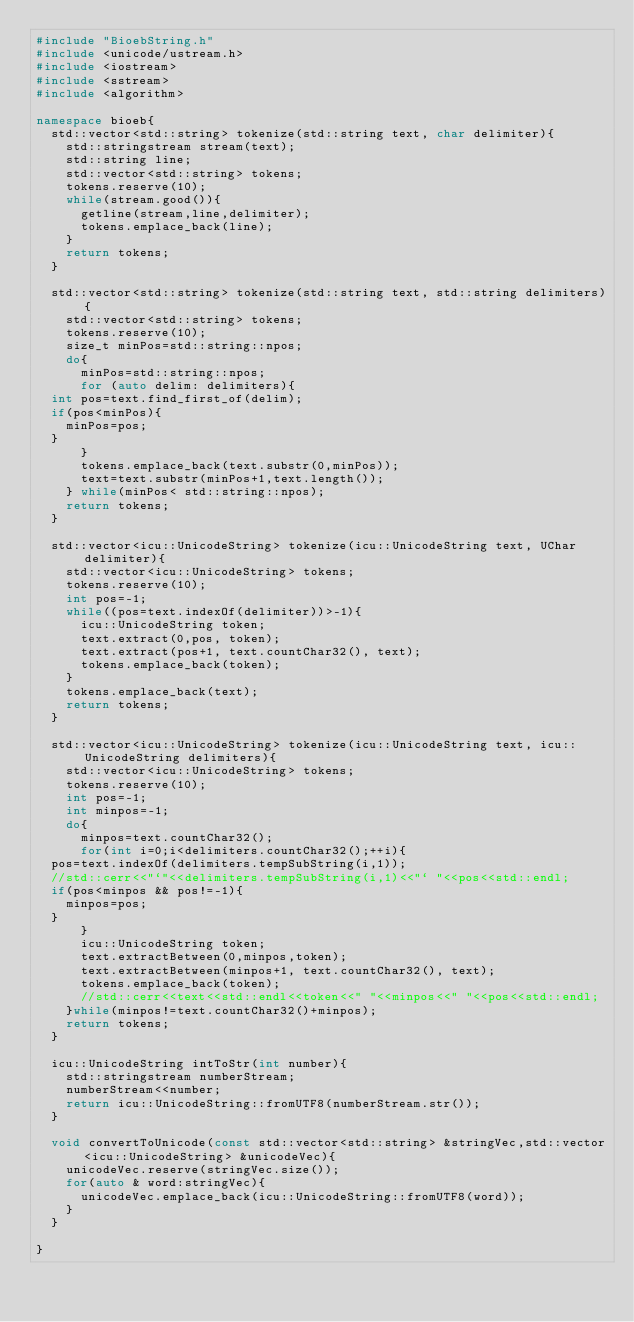Convert code to text. <code><loc_0><loc_0><loc_500><loc_500><_C++_>#include "BioebString.h"
#include <unicode/ustream.h>
#include <iostream>
#include <sstream>
#include <algorithm>

namespace bioeb{
  std::vector<std::string> tokenize(std::string text, char delimiter){
    std::stringstream stream(text);
    std::string line;
    std::vector<std::string> tokens;
    tokens.reserve(10);
    while(stream.good()){
      getline(stream,line,delimiter);
      tokens.emplace_back(line);
    }
    return tokens;
  }

  std::vector<std::string> tokenize(std::string text, std::string delimiters){
    std::vector<std::string> tokens;
    tokens.reserve(10);
    size_t minPos=std::string::npos;
    do{
      minPos=std::string::npos;
      for (auto delim: delimiters){
	int pos=text.find_first_of(delim);
	if(pos<minPos){
	  minPos=pos;
	}
      }
      tokens.emplace_back(text.substr(0,minPos));
      text=text.substr(minPos+1,text.length());
    } while(minPos< std::string::npos);
    return tokens;
  }

  std::vector<icu::UnicodeString> tokenize(icu::UnicodeString text, UChar delimiter){
    std::vector<icu::UnicodeString> tokens;
    tokens.reserve(10);
    int pos=-1;
    while((pos=text.indexOf(delimiter))>-1){
      icu::UnicodeString token;
      text.extract(0,pos, token);
      text.extract(pos+1, text.countChar32(), text);
      tokens.emplace_back(token);
    }
    tokens.emplace_back(text);
    return tokens;
  }

  std::vector<icu::UnicodeString> tokenize(icu::UnicodeString text, icu::UnicodeString delimiters){
    std::vector<icu::UnicodeString> tokens;
    tokens.reserve(10);
    int pos=-1;
    int minpos=-1;
    do{
      minpos=text.countChar32();
      for(int i=0;i<delimiters.countChar32();++i){
	pos=text.indexOf(delimiters.tempSubString(i,1));
	//std::cerr<<"`"<<delimiters.tempSubString(i,1)<<"` "<<pos<<std::endl;
	if(pos<minpos && pos!=-1){
	  minpos=pos;
	}
      }
      icu::UnicodeString token;
      text.extractBetween(0,minpos,token);
      text.extractBetween(minpos+1, text.countChar32(), text);
      tokens.emplace_back(token);
      //std::cerr<<text<<std::endl<<token<<" "<<minpos<<" "<<pos<<std::endl;
    }while(minpos!=text.countChar32()+minpos);
    return tokens;
  }

  icu::UnicodeString intToStr(int number){
    std::stringstream numberStream;
    numberStream<<number;
    return icu::UnicodeString::fromUTF8(numberStream.str());
  }

  void convertToUnicode(const std::vector<std::string> &stringVec,std::vector<icu::UnicodeString> &unicodeVec){
    unicodeVec.reserve(stringVec.size());
    for(auto & word:stringVec){
      unicodeVec.emplace_back(icu::UnicodeString::fromUTF8(word));
    }
  }

}
</code> 